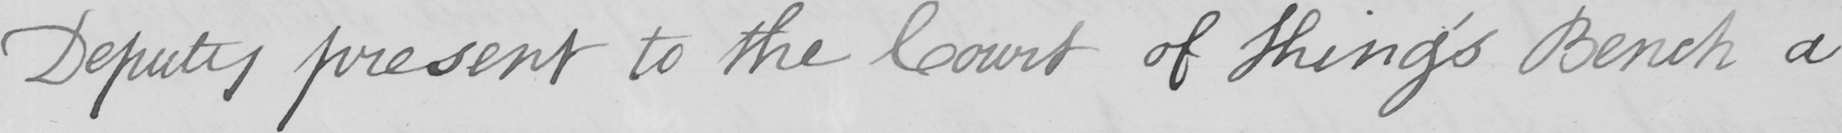Transcribe the text shown in this historical manuscript line. Deputy present to the Court of King ' s Bench a 